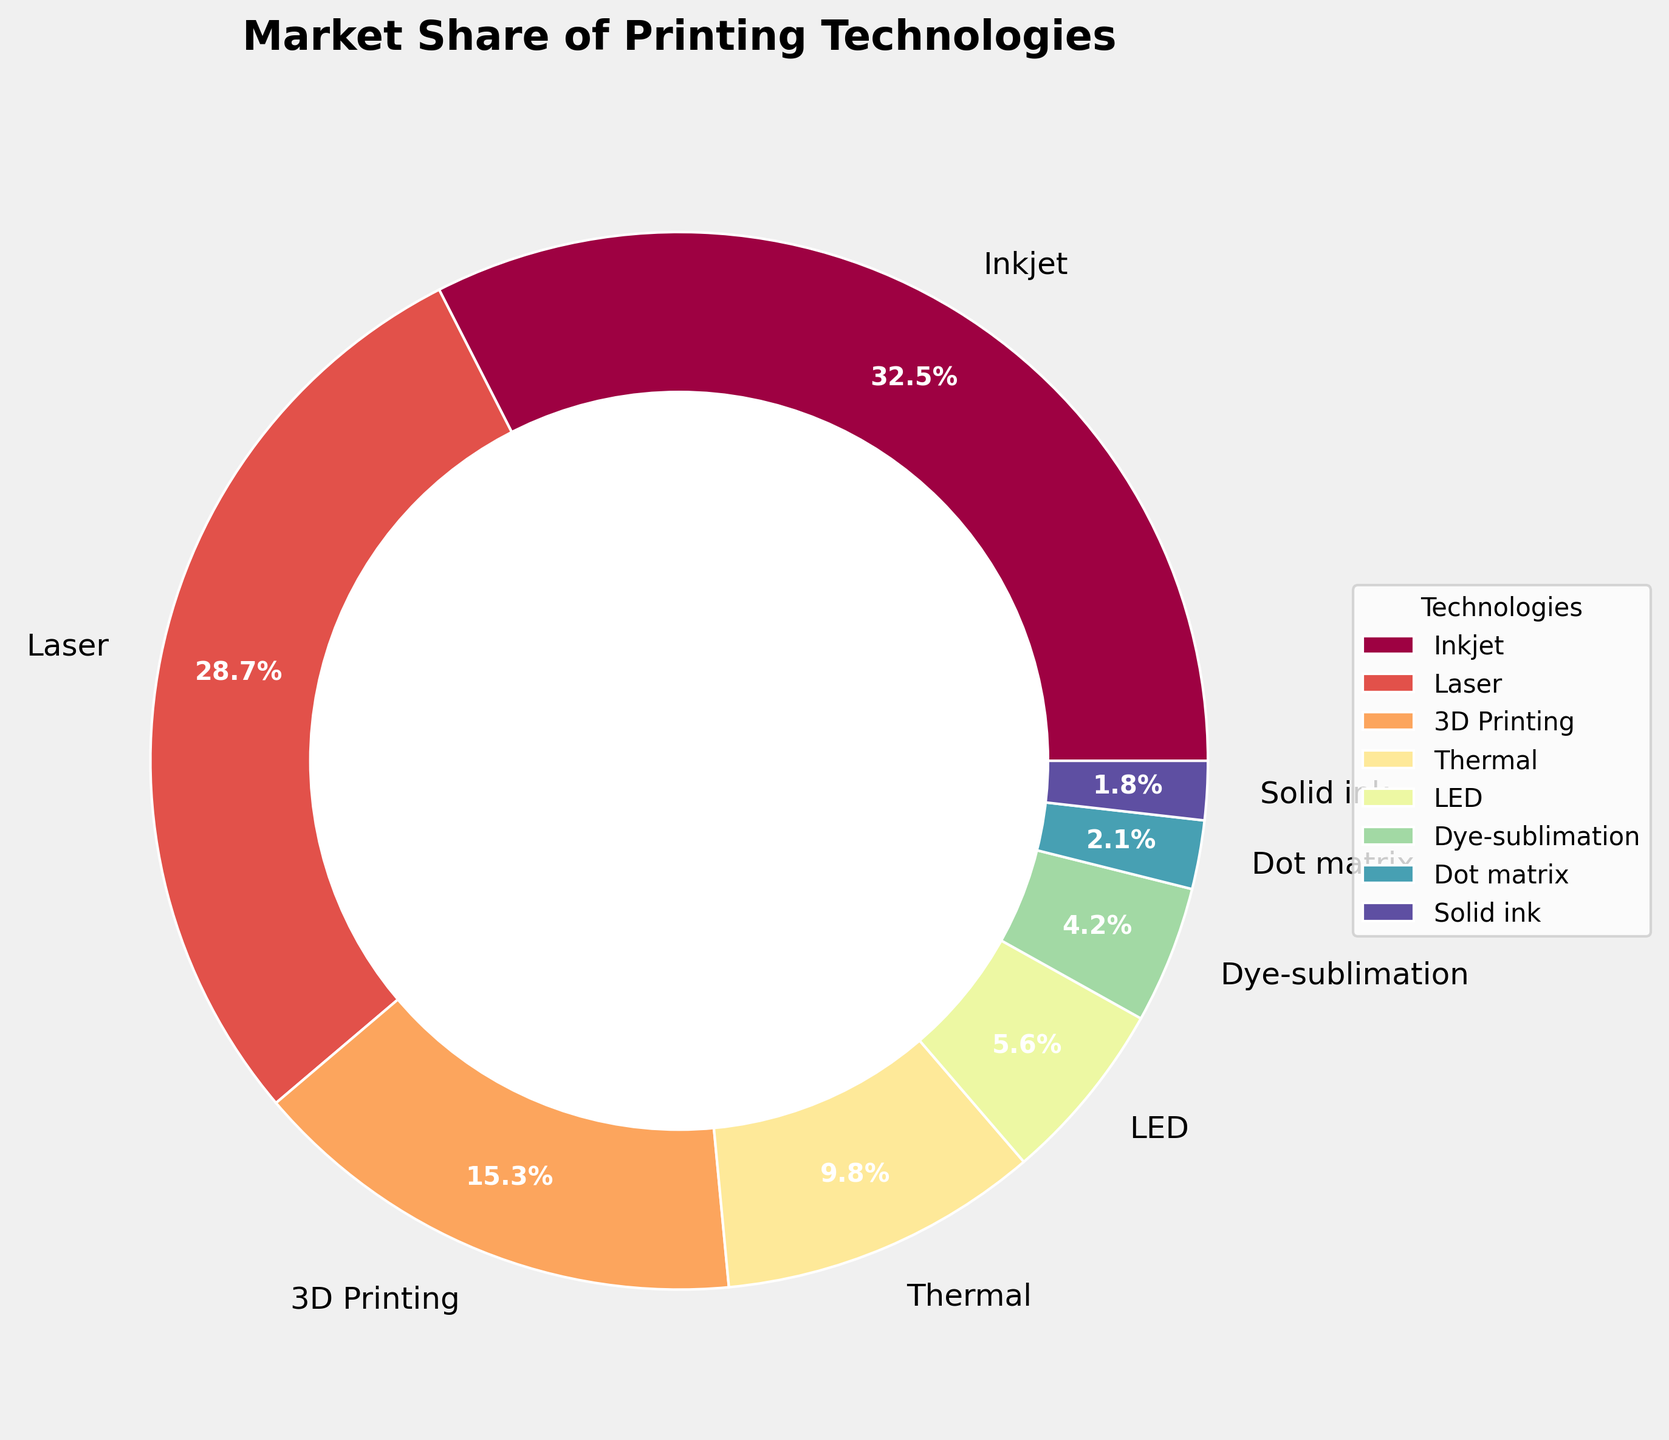What printing technology has the highest market share? The pie chart shows the market shares of different printing technologies. The technology with the largest wedge represents the highest market share, which is "Inkjet" with 32.5%.
Answer: Inkjet Which printing technology has a market share of less than 5%? The pie chart displays the market shares of multiple printing technologies, and the ones with wedges corresponding to less than 5% are "Dye-sublimation" (4.2%), "Dot matrix" (2.1%), and "Solid ink" (1.8%).
Answer: Dye-sublimation, Dot matrix, Solid ink What is the total market share of both Inkjet and Laser printing technologies combined? To find the combined market share, add the market shares of "Inkjet" (32.5%) and "Laser" (28.7%). 32.5% + 28.7% = 61.2%.
Answer: 61.2% Which printing technology has the smallest market share, and what is its value? By examining the pie chart, the smallest wedge represents "Solid ink" which has a market share of 1.8%.
Answer: Solid ink, 1.8% Is the market share of 3D Printing more than double that of Thermal printing? The market share of "3D Printing" is 15.3%, while "Thermal" has 9.8%. Doubling 9.8% (2 * 9.8% = 19.6%) shows that 15.3% is not more than double 9.8%.
Answer: No What is the combined market share of the least three popular technologies? The least three popular technologies are "Solid ink" (1.8%), "Dot matrix" (2.1%), and "Dye-sublimation" (4.2%). Adding them gives 1.8% + 2.1% + 4.2% = 8.1%.
Answer: 8.1% Which technology has a higher market share: Thermal or 3D Printing? By referring to the pie chart, "3D Printing" has a market share of 15.3%, while "Thermal" has 9.8%. Thus, "3D Printing" has a higher market share.
Answer: 3D Printing 